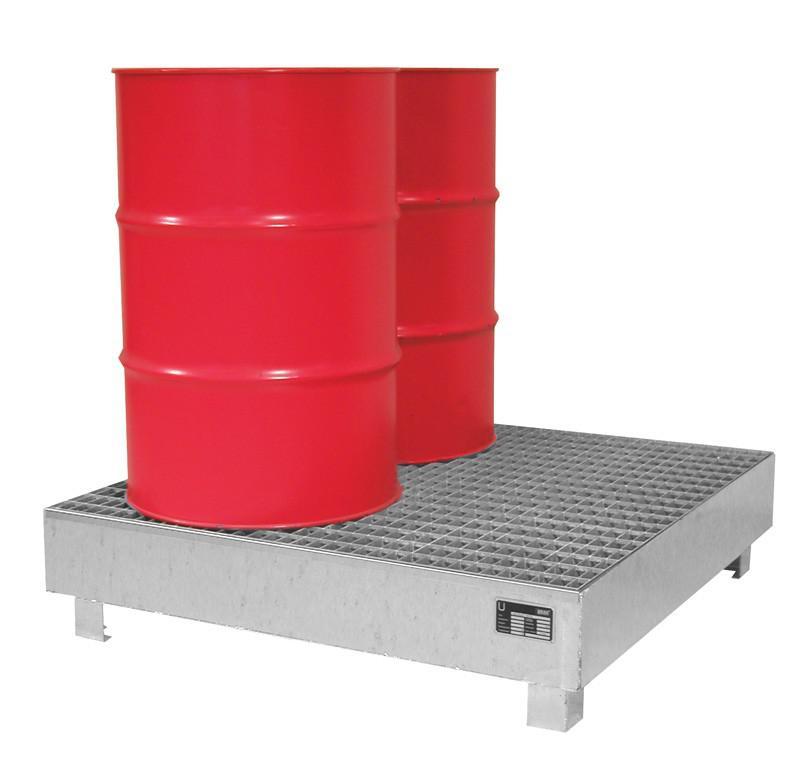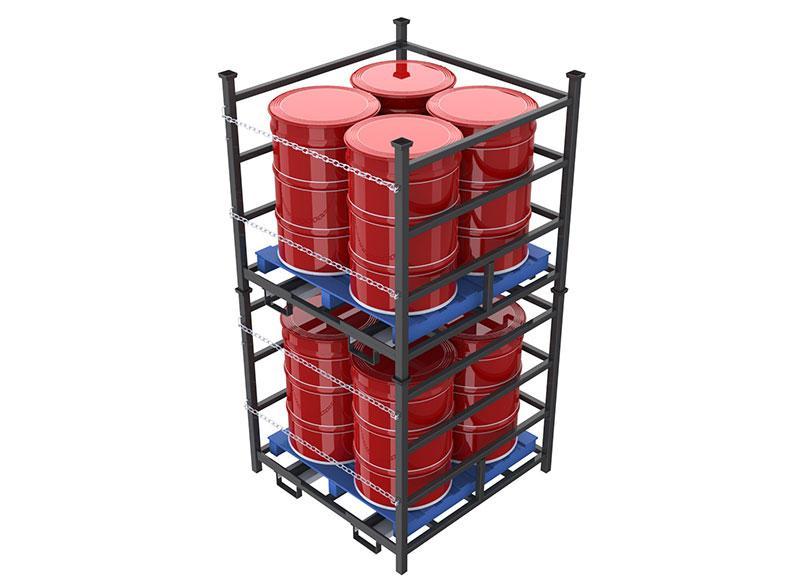The first image is the image on the left, the second image is the image on the right. For the images shown, is this caption "One image shows at least one cube-shaped black frame that contains four upright red barrels on a blue base." true? Answer yes or no. Yes. 